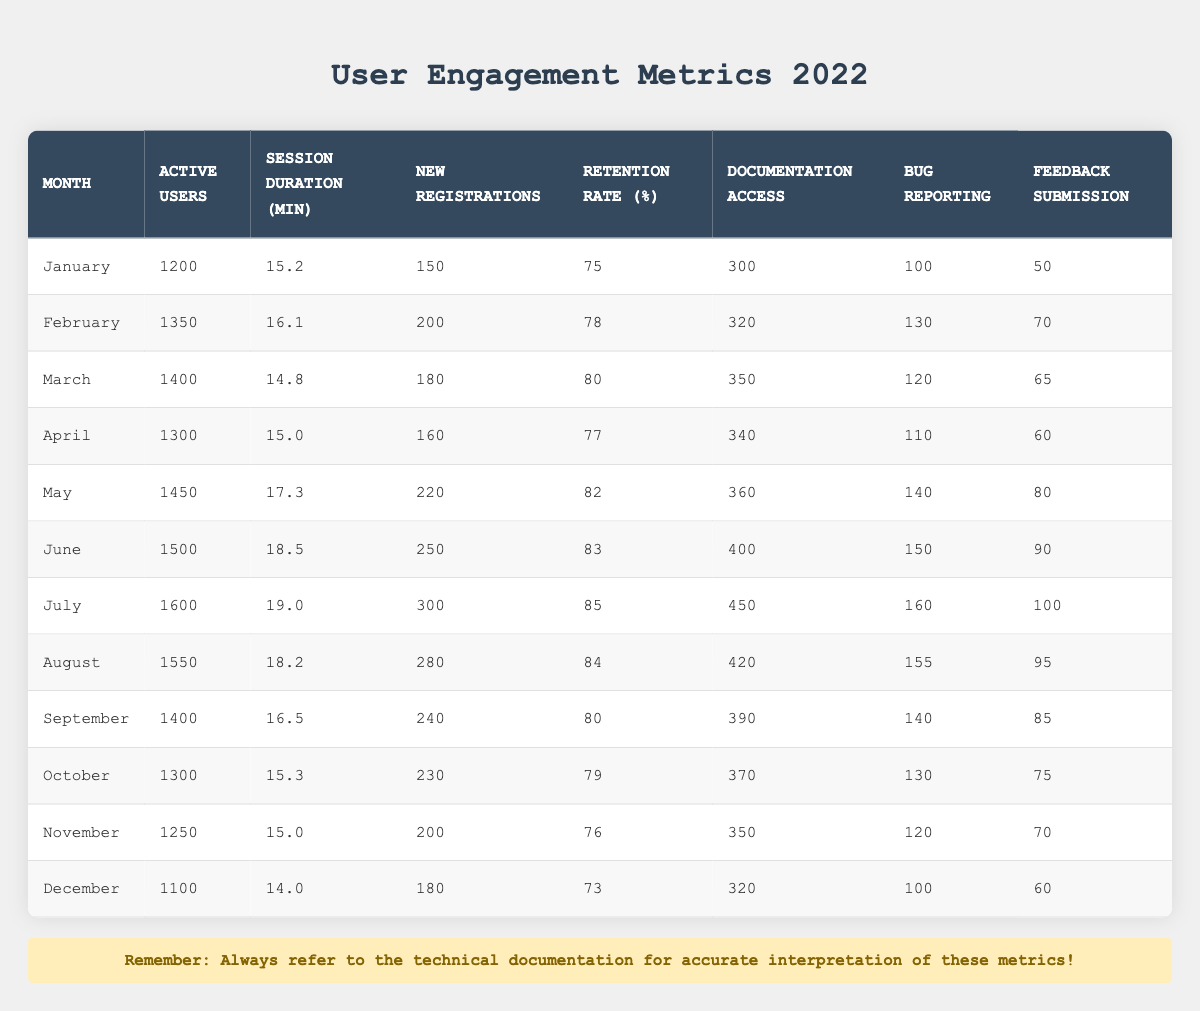What is the highest number of active users in a single month? By checking the "Active Users" column, the highest number is found in July with 1600 users.
Answer: 1600 In which month was the session duration the longest? The "Session Duration" column shows the highest value of 19.0 minutes in July.
Answer: July What is the average retention rate for the second half of the year (July to December)? To find this, add the retention rates for July (85), August (84), September (80), October (79), November (76), and December (73), which sums up to 477. Then, divide by 6 (the number of months): 477 / 6 = 79.5.
Answer: 79.5 Did the number of new registrations increase every month? A quick review shows that January (150) to May (220) sees increases, but June to July (from 250 to 300) increases; August (280) sees a decrease. Therefore, it did not increase every month.
Answer: No What is the total amount of documentation access throughout the year? Add all values from the "Documentation Access" column: 300 + 320 + 350 + 340 + 360 + 400 + 450 + 420 + 390 + 370 + 350 + 320 = 4,360.
Answer: 4360 What was the month with the lowest retention rate? Looking at the "Retention Rate" column, December has the lowest value of 73%.
Answer: December How many active users were there in the months with a retention rate of 80% or above? The months with retention rates at or above 80% are March (1400), May (1450), June (1500), and July (1600). Adding these gives 1400 + 1450 + 1500 + 1600 = 4950.
Answer: 4950 What is the change in active users from January to December? January has 1200 active users and December has 1100, so the change is 1100 - 1200 = -100, indicating a decrease.
Answer: -100 Which month had the highest feature usage for bug reporting? By checking the "Bug Reporting" numbers, July has the highest usage with 160 reports submitted.
Answer: July 